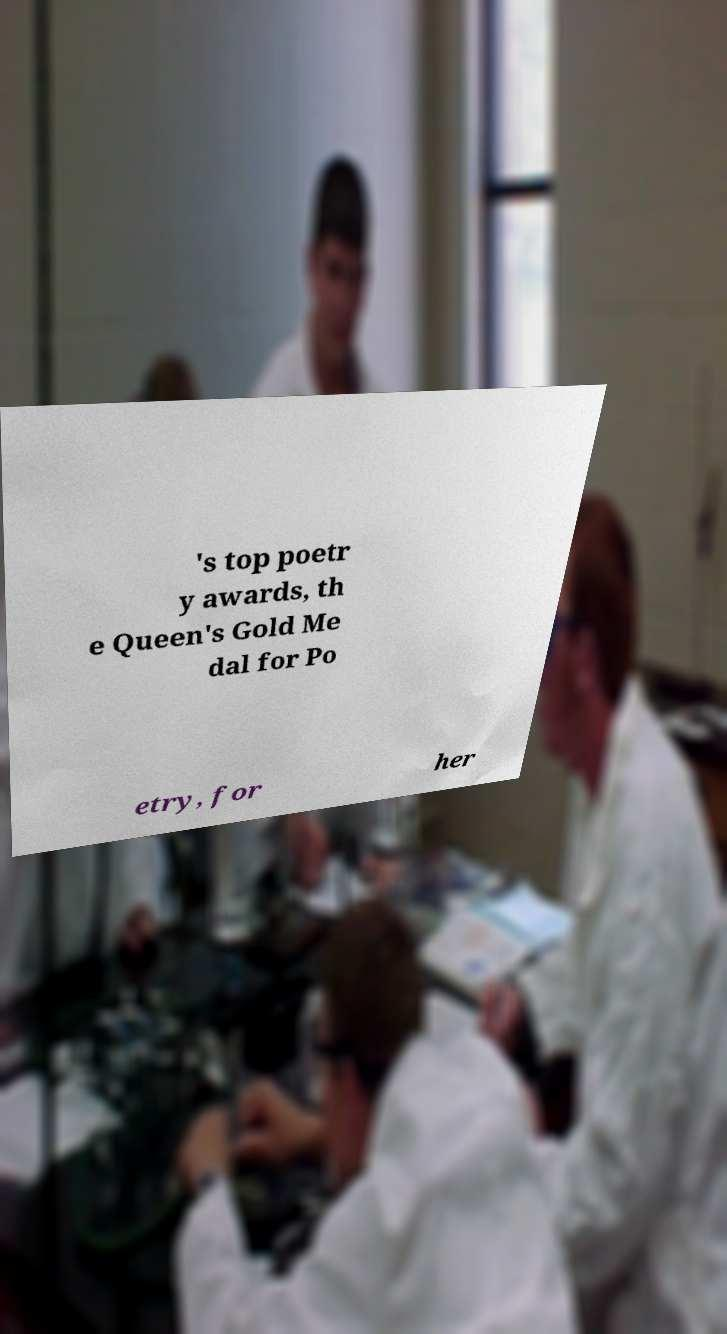What messages or text are displayed in this image? I need them in a readable, typed format. 's top poetr y awards, th e Queen's Gold Me dal for Po etry, for her 